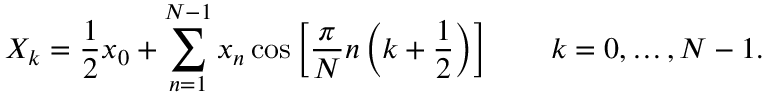<formula> <loc_0><loc_0><loc_500><loc_500>X _ { k } = { \frac { 1 } { 2 } } x _ { 0 } + \sum _ { n = 1 } ^ { N - 1 } x _ { n } \cos \left [ { \frac { \pi } { N } } n \left ( k + { \frac { 1 } { 2 } } \right ) \right ] \quad k = 0 , \dots , N - 1 .</formula> 